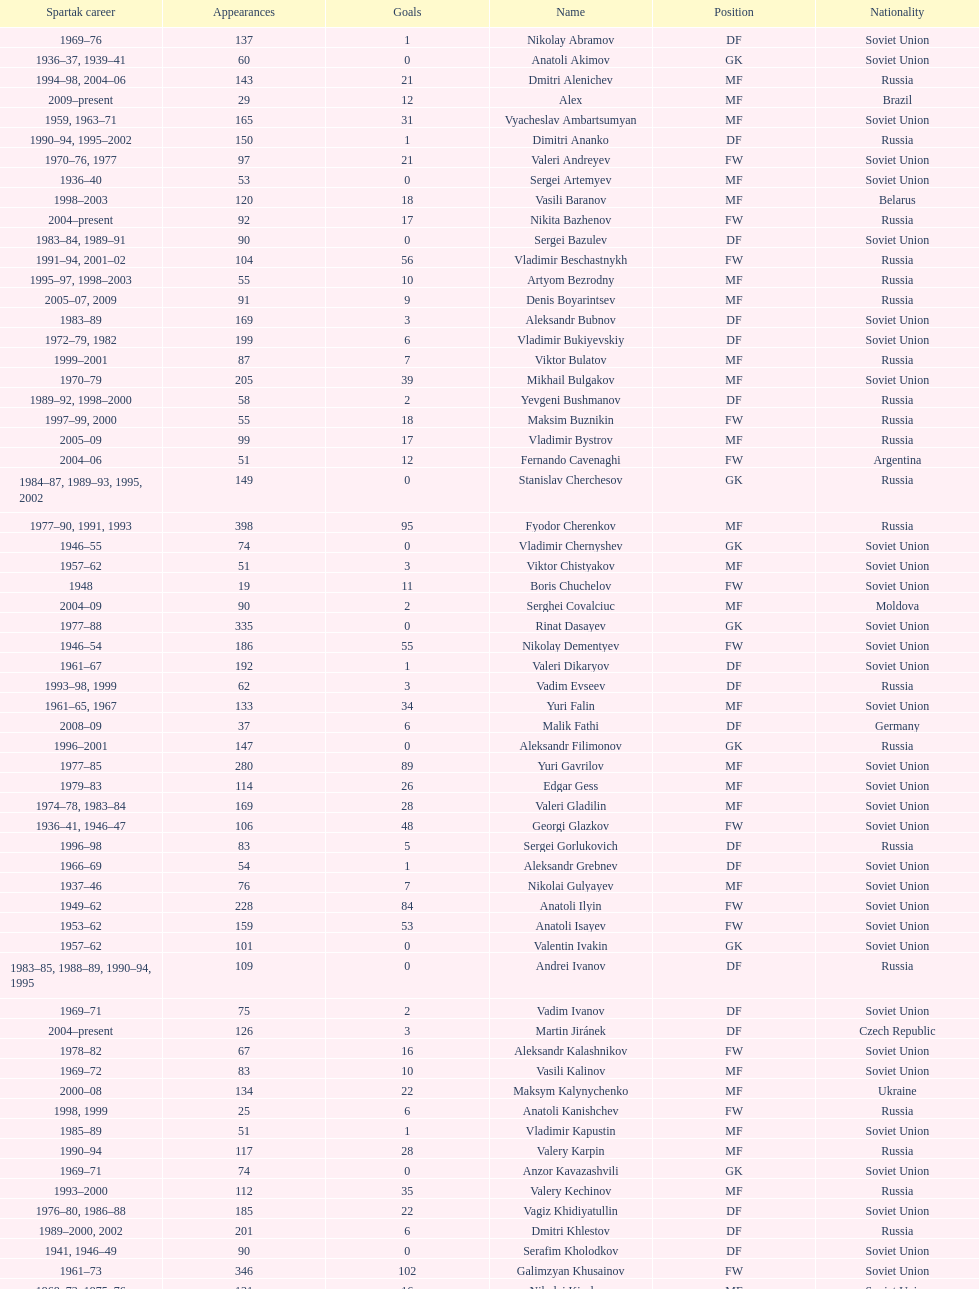Who had the highest number of appearances? Fyodor Cherenkov. 